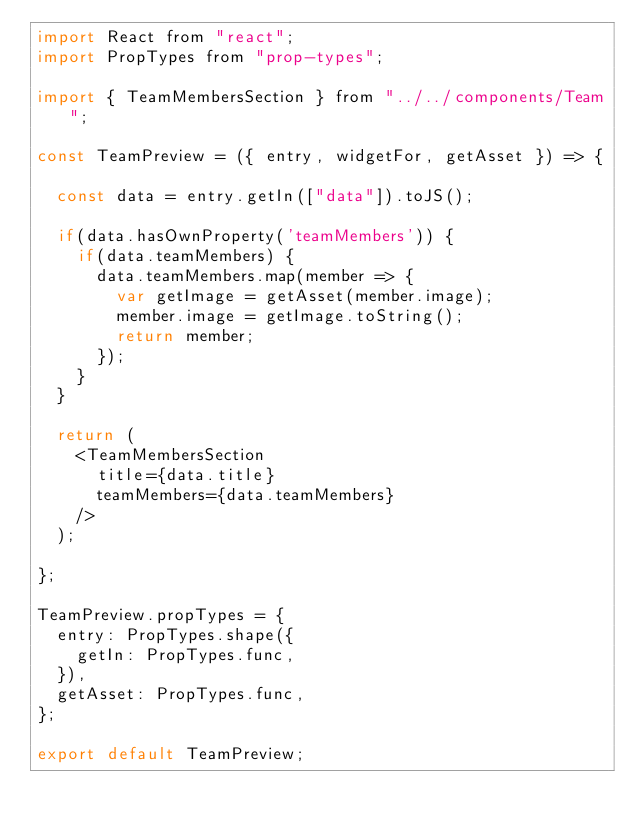<code> <loc_0><loc_0><loc_500><loc_500><_JavaScript_>import React from "react";
import PropTypes from "prop-types";

import { TeamMembersSection } from "../../components/Team";

const TeamPreview = ({ entry, widgetFor, getAsset }) => {

  const data = entry.getIn(["data"]).toJS();

  if(data.hasOwnProperty('teamMembers')) {
    if(data.teamMembers) {
      data.teamMembers.map(member => {
        var getImage = getAsset(member.image);
        member.image = getImage.toString();
        return member;
      });
    }
  }

  return (
    <TeamMembersSection
      title={data.title}
      teamMembers={data.teamMembers}
    />
  );

};

TeamPreview.propTypes = {
  entry: PropTypes.shape({
    getIn: PropTypes.func,
  }),
  getAsset: PropTypes.func,
};

export default TeamPreview;
</code> 